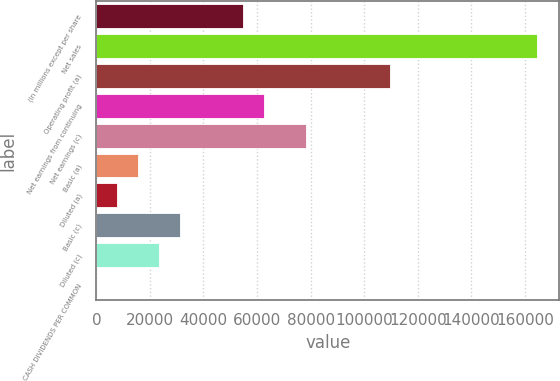<chart> <loc_0><loc_0><loc_500><loc_500><bar_chart><fcel>(In millions except per share<fcel>Net sales<fcel>Operating profit (a)<fcel>Net earnings from continuing<fcel>Net earnings (c)<fcel>Basic (a)<fcel>Diluted (a)<fcel>Basic (c)<fcel>Diluted (c)<fcel>CASH DIVIDENDS PER COMMON<nl><fcel>54880.8<fcel>164637<fcel>109759<fcel>62720.6<fcel>78400<fcel>15682.1<fcel>7842.38<fcel>31361.6<fcel>23521.9<fcel>2.64<nl></chart> 